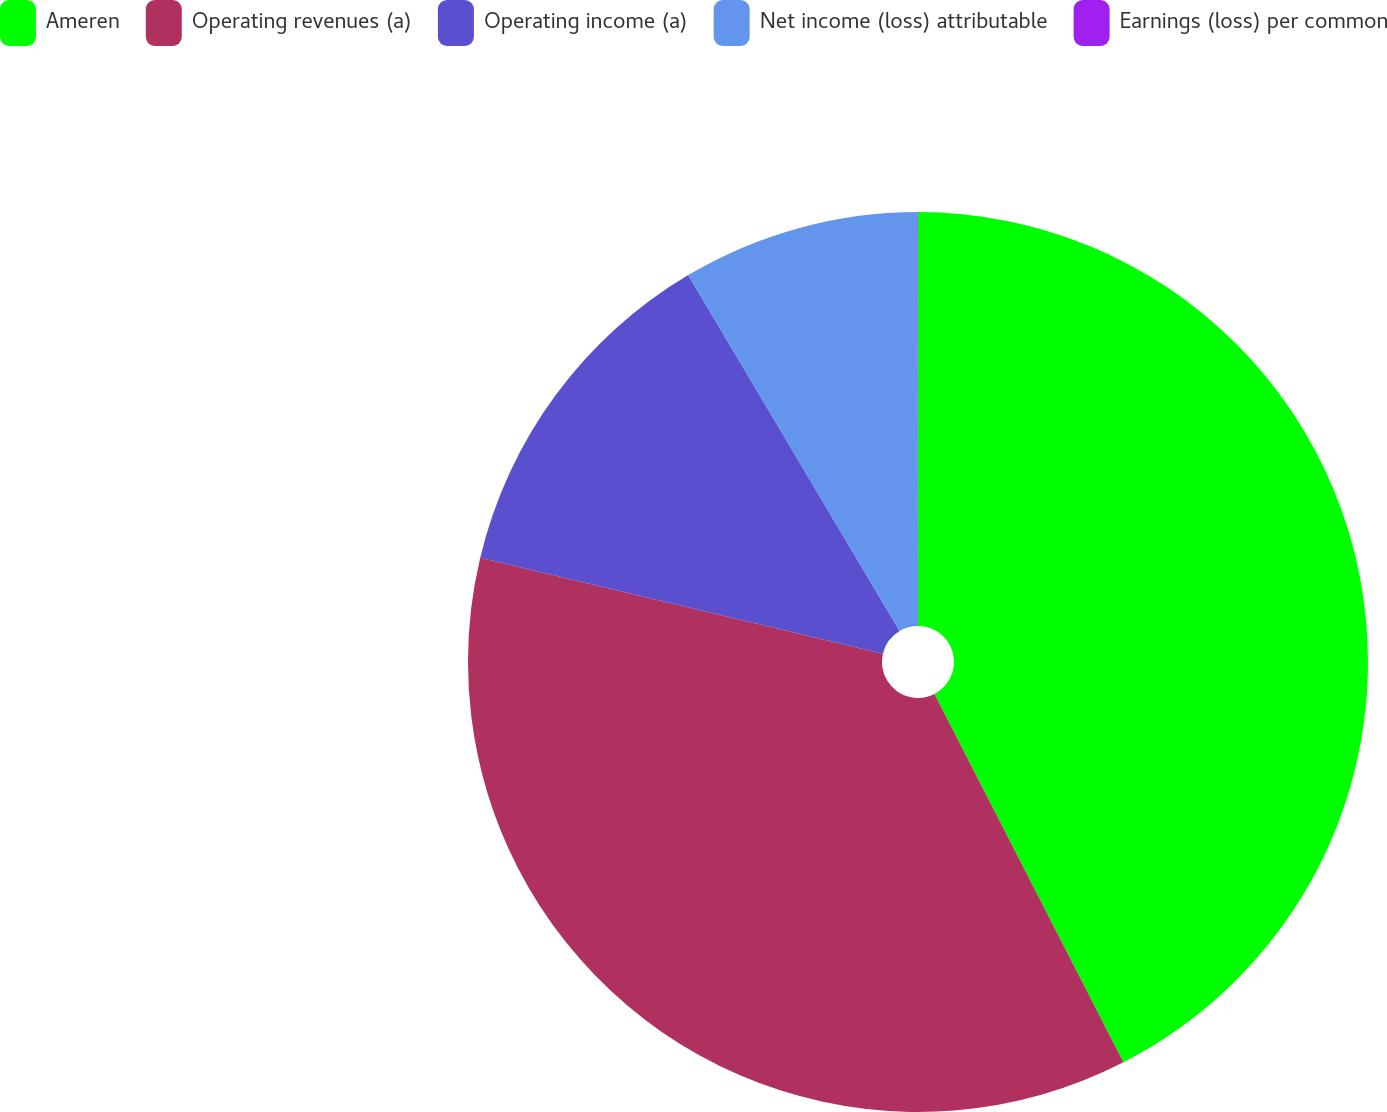<chart> <loc_0><loc_0><loc_500><loc_500><pie_chart><fcel>Ameren<fcel>Operating revenues (a)<fcel>Operating income (a)<fcel>Net income (loss) attributable<fcel>Earnings (loss) per common<nl><fcel>42.45%<fcel>36.26%<fcel>12.75%<fcel>8.51%<fcel>0.02%<nl></chart> 